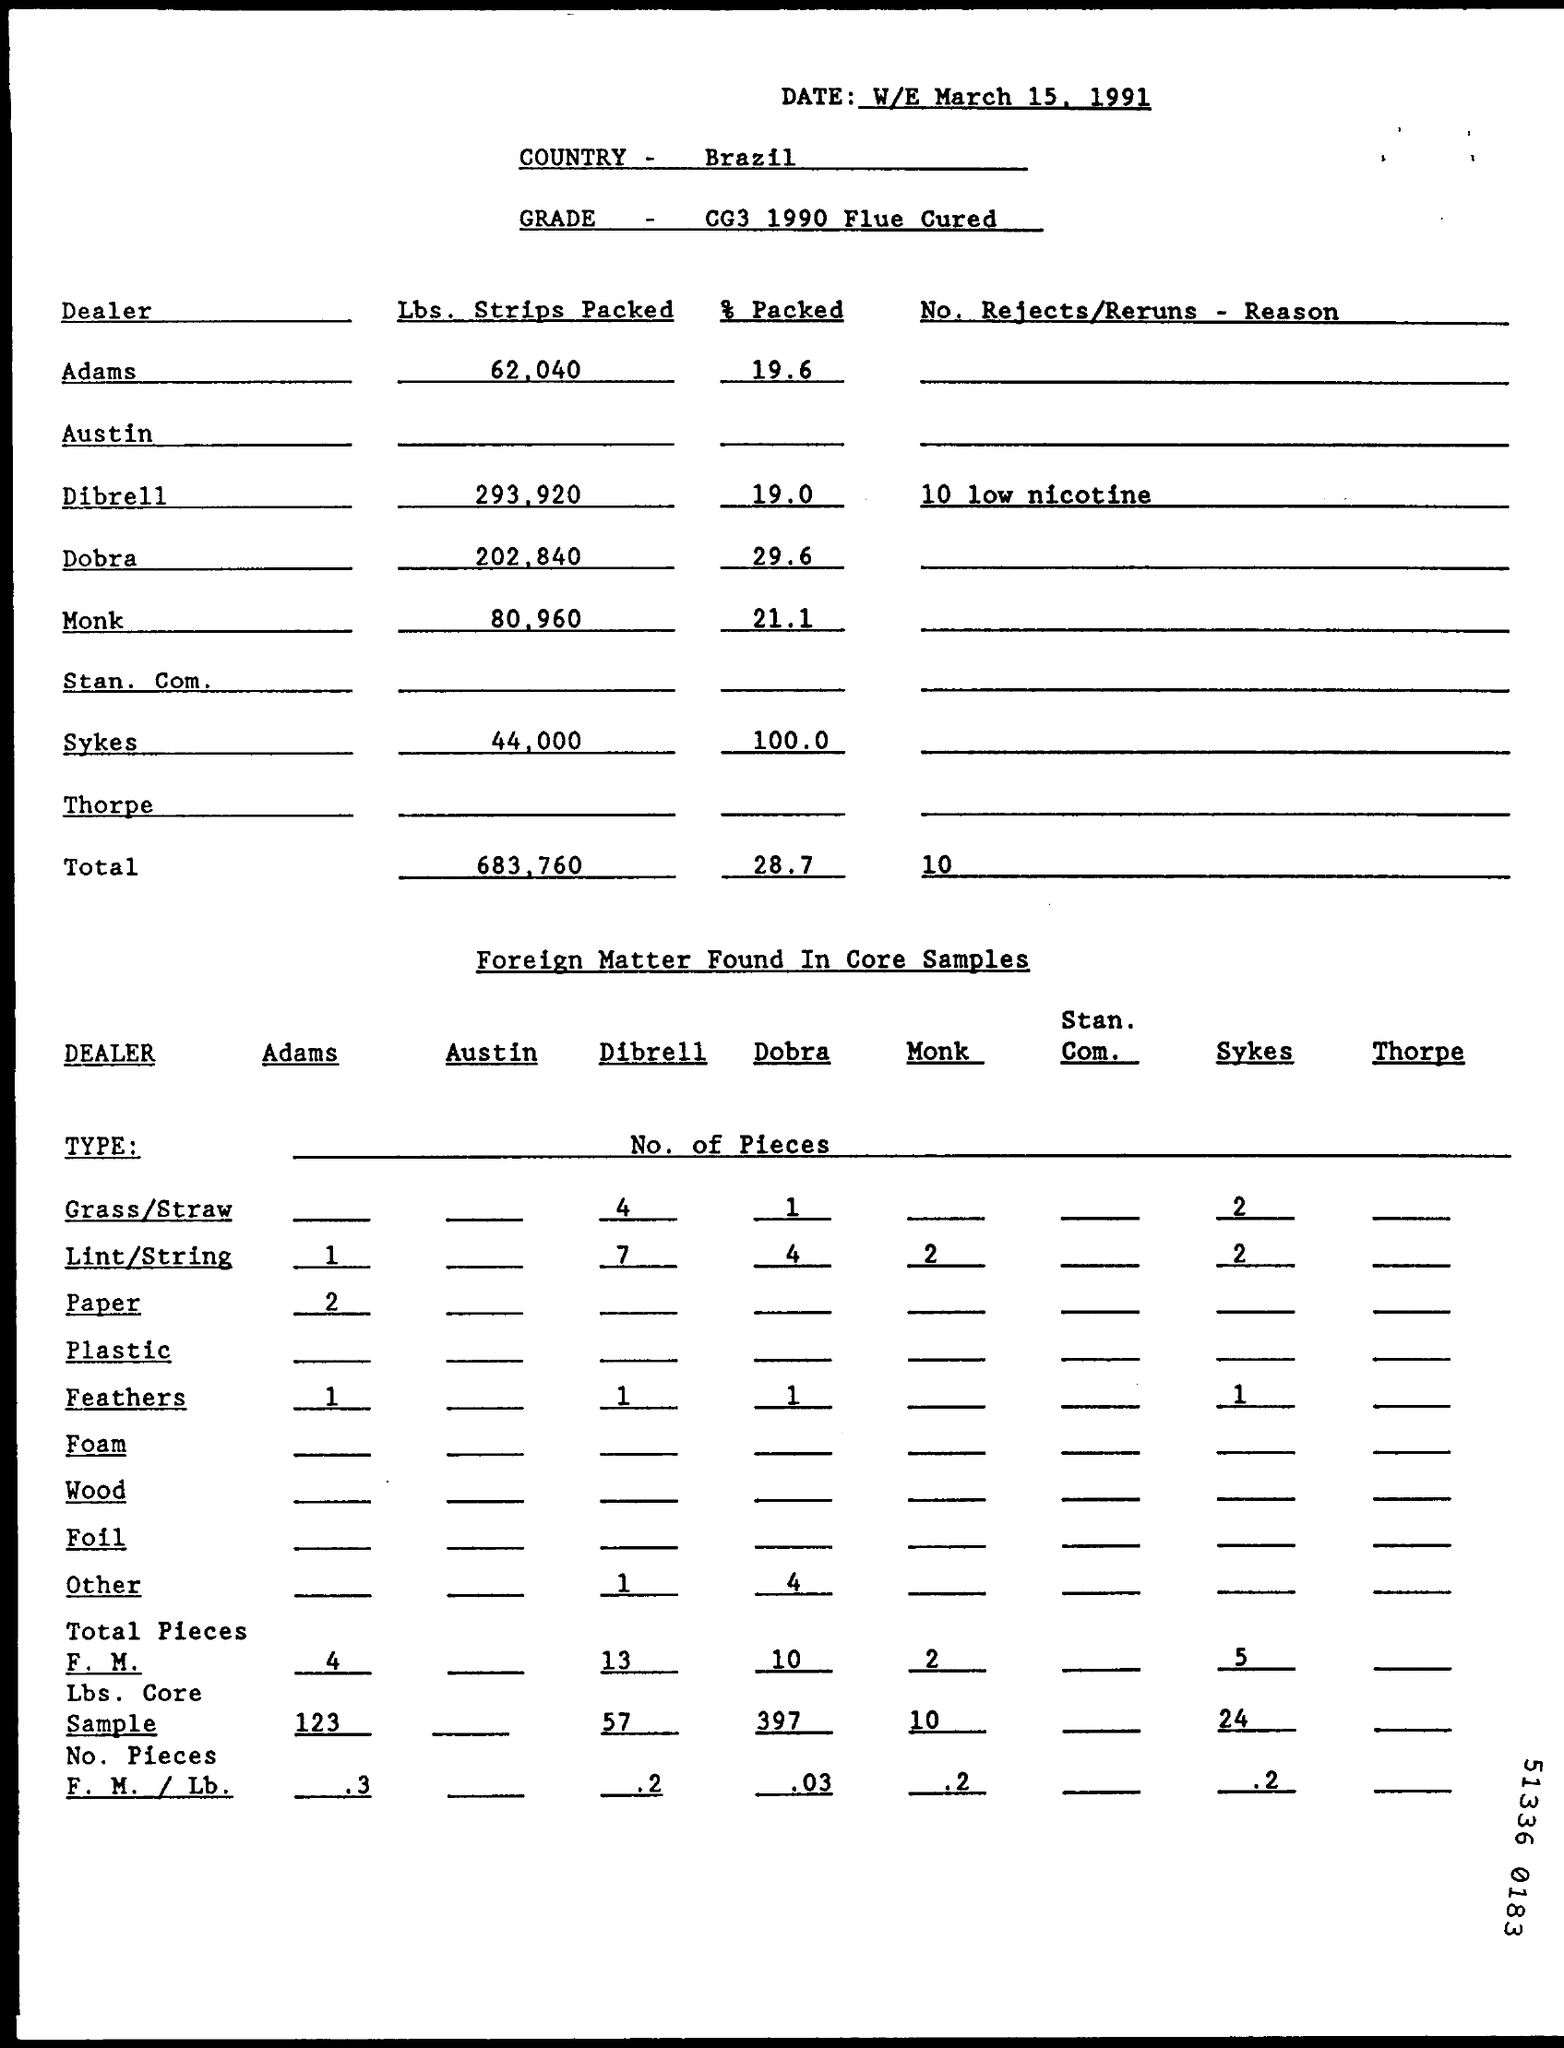List a handful of essential elements in this visual. There is a total count of 10 rejected or returned items, and the reasons for the rejection or return are currently unknown. The GRADE field contains the information 'CG3 1990 Flue Cured', which refers to a specific type of tobacco. 